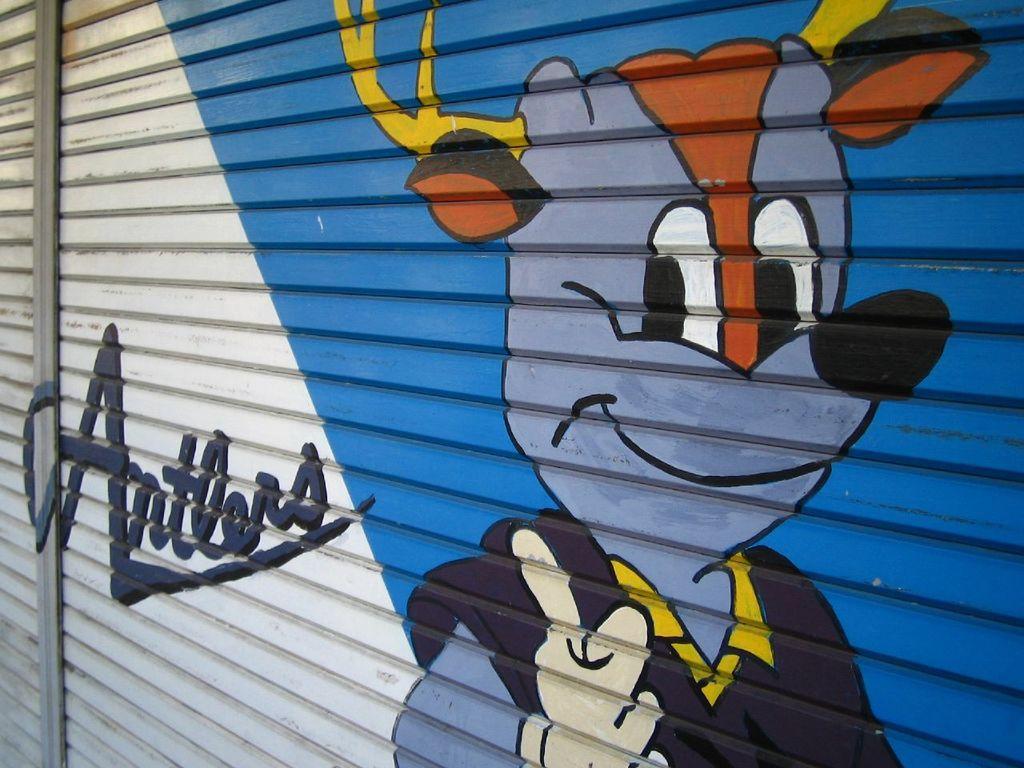In one or two sentences, can you explain what this image depicts? In this image I can see the rolling shutter and on the rolling shutter I can see the painting of an animal which is orange, black and blue in color. I can see the shutter is blue and white in color. 